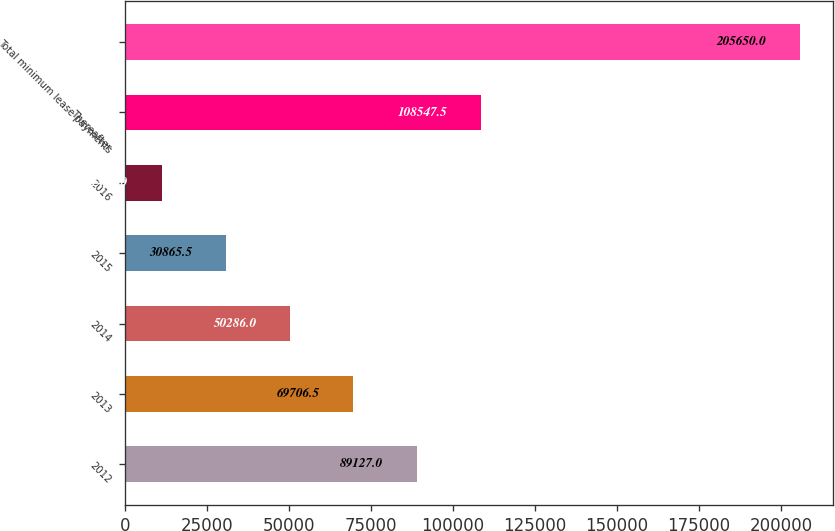Convert chart. <chart><loc_0><loc_0><loc_500><loc_500><bar_chart><fcel>2012<fcel>2013<fcel>2014<fcel>2015<fcel>2016<fcel>Thereafter<fcel>Total minimum lease payments<nl><fcel>89127<fcel>69706.5<fcel>50286<fcel>30865.5<fcel>11445<fcel>108548<fcel>205650<nl></chart> 